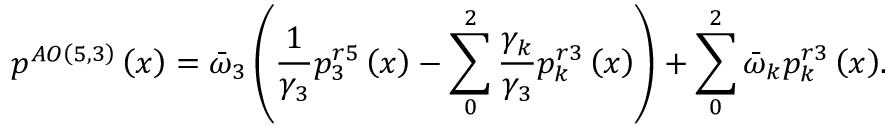Convert formula to latex. <formula><loc_0><loc_0><loc_500><loc_500>{ { p } ^ { A O \left ( 5 , 3 \right ) } } \left ( x \right ) = { { \bar { \omega } } _ { 3 } } \left ( \frac { 1 } { { { \gamma } _ { 3 } } } p _ { 3 } ^ { r 5 } \left ( x \right ) - \sum _ { 0 } ^ { 2 } { \frac { { { \gamma } _ { k } } } { { { \gamma } _ { 3 } } } p _ { k } ^ { r 3 } \left ( x \right ) } \right ) + \sum _ { 0 } ^ { 2 } { { { { \bar { \omega } } } _ { k } } p _ { k } ^ { r 3 } \left ( x \right ) } .</formula> 